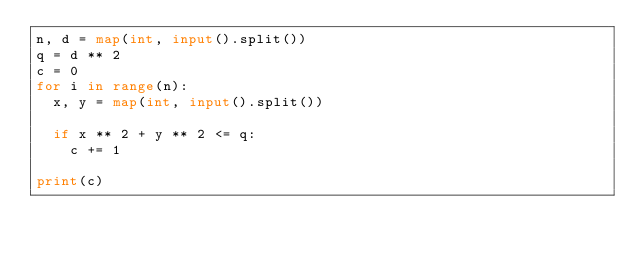Convert code to text. <code><loc_0><loc_0><loc_500><loc_500><_Python_>n, d = map(int, input().split())
q = d ** 2
c = 0
for i in range(n):
  x, y = map(int, input().split())
  
  if x ** 2 + y ** 2 <= q:
    c += 1

print(c)</code> 